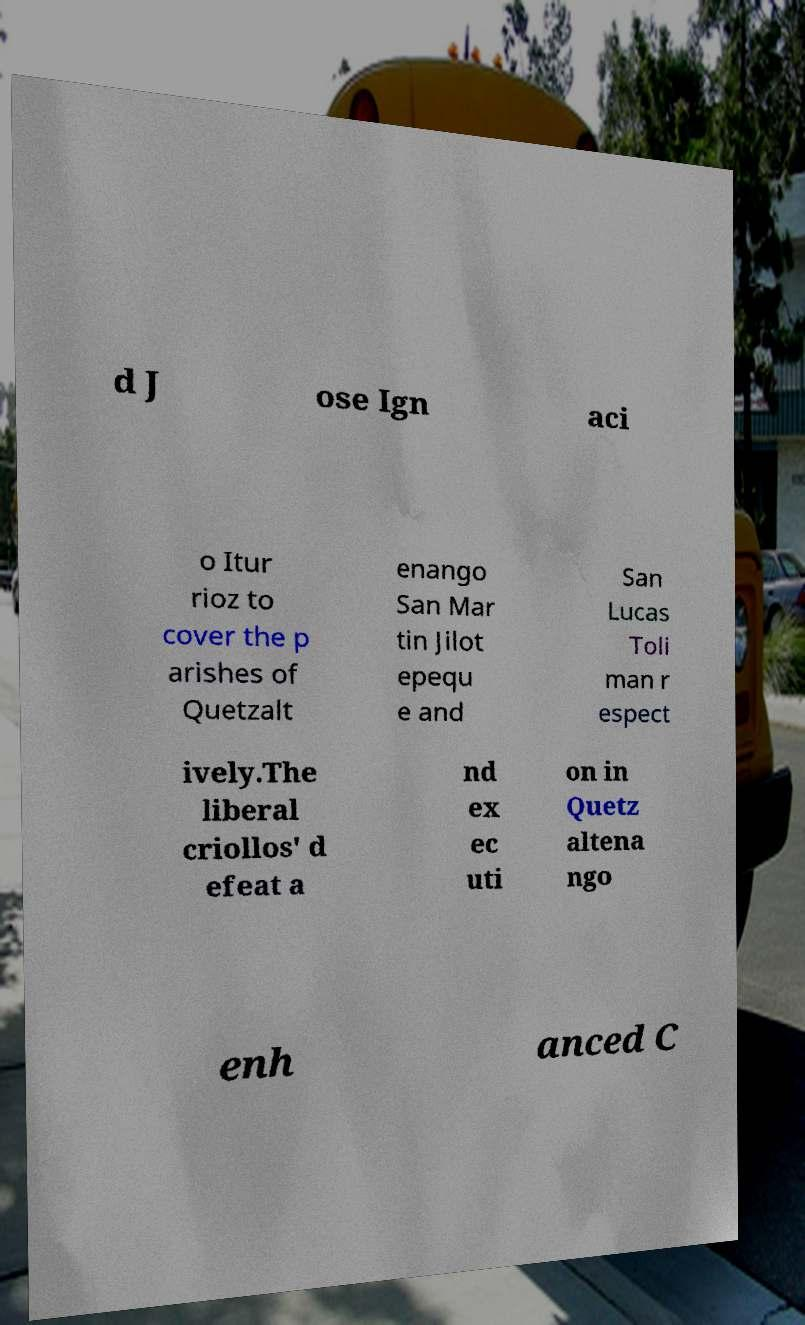Can you read and provide the text displayed in the image?This photo seems to have some interesting text. Can you extract and type it out for me? d J ose Ign aci o Itur rioz to cover the p arishes of Quetzalt enango San Mar tin Jilot epequ e and San Lucas Toli man r espect ively.The liberal criollos' d efeat a nd ex ec uti on in Quetz altena ngo enh anced C 